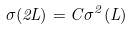Convert formula to latex. <formula><loc_0><loc_0><loc_500><loc_500>\sigma ( 2 L ) = C \sigma ^ { 2 } ( L )</formula> 